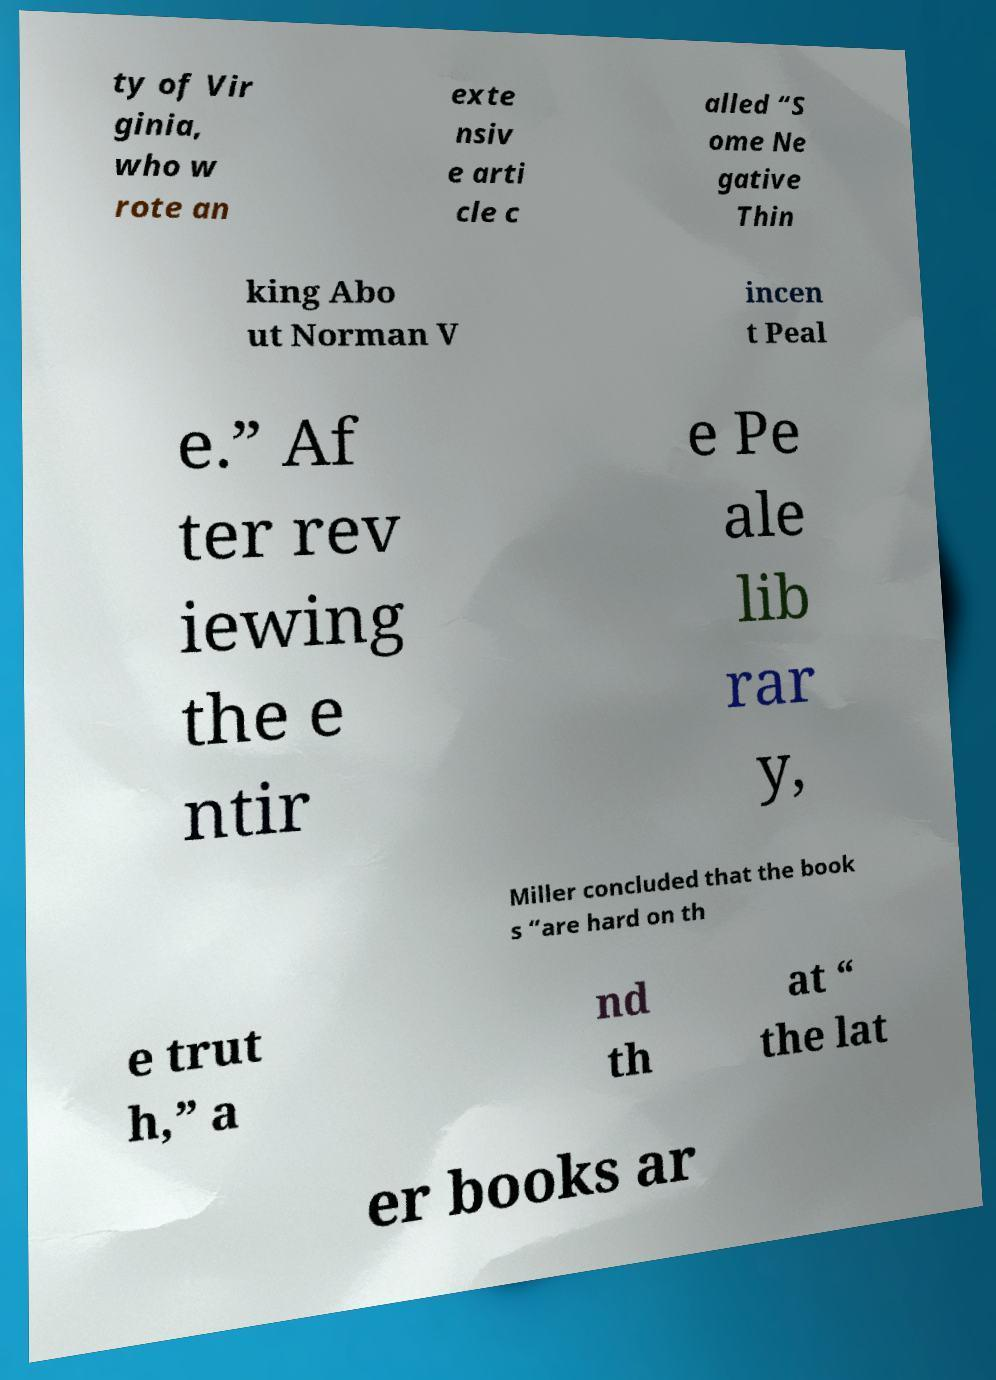Can you read and provide the text displayed in the image?This photo seems to have some interesting text. Can you extract and type it out for me? ty of Vir ginia, who w rote an exte nsiv e arti cle c alled “S ome Ne gative Thin king Abo ut Norman V incen t Peal e.” Af ter rev iewing the e ntir e Pe ale lib rar y, Miller concluded that the book s “are hard on th e trut h,” a nd th at “ the lat er books ar 